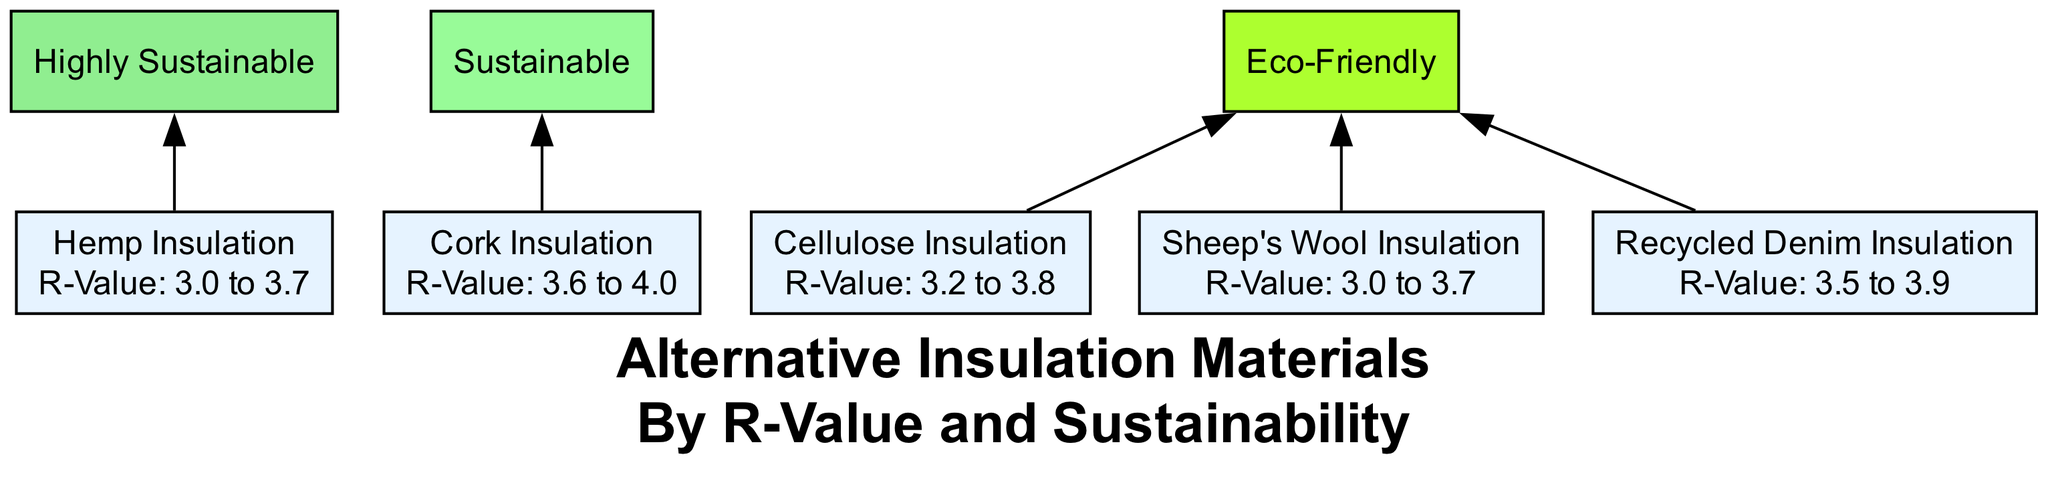What are the R-values for Cork Insulation? The R-value for Cork Insulation is indicated in the diagram as "3.6 to 4.0". This value is presented directly under the name of the material.
Answer: 3.6 to 4.0 How many insulation materials are highly sustainable? By inspecting the diagram, it shows that three materials are linked to the "Highly Sustainable" category: Hemp Insulation, Sheep's Wool Insulation, and Cork Insulation. By counting these connections, we find the total.
Answer: 3 Which insulation material has the lowest R-value range? The diagram presents the R-value range for Hemp Insulation and Sheep's Wool Insulation as "3.0 to 3.7", which is the lowest among all listed materials in terms of the lower limit.
Answer: Hemp Insulation or Sheep's Wool Insulation Which insulation option is made from recycled paper? Cellulose Insulation is the only material that is stated to be made from recycled paper in the diagram. It is directly represented as a node, and its sustainability information supports this claim.
Answer: Cellulose Insulation What connection exists between Recycled Denim Insulation and sustainability? The diagram indicates a connection from Recycled Denim Insulation to the "Eco-Friendly" sustainability category, demonstrating that it is classified within that specific sustainability type.
Answer: Eco-Friendly Which insulation material has the widest R-value range? Comparing the R-value ranges from the diagram, Cork Insulation has the widest range, from 3.6 to 4.0, when including its potential upper limit. By examining the ranges, it can be determined that this is indeed the widest in the chart.
Answer: Cork Insulation What color represents "Sustainable" in the diagram? The diagram uses a specific color for the "Sustainable" category, which can be identified visually as a pale green shade. This color code is noted within the sustainability categories section of the diagram.
Answer: Pale green Which material is characterized as made from post-consumer textile waste? In the diagram, Recycled Denim Insulation is labeled as made from post-consumer textile waste, which is part of its sustainable production approach outlined in the diagram alongside its R-value.
Answer: Recycled Denim Insulation 